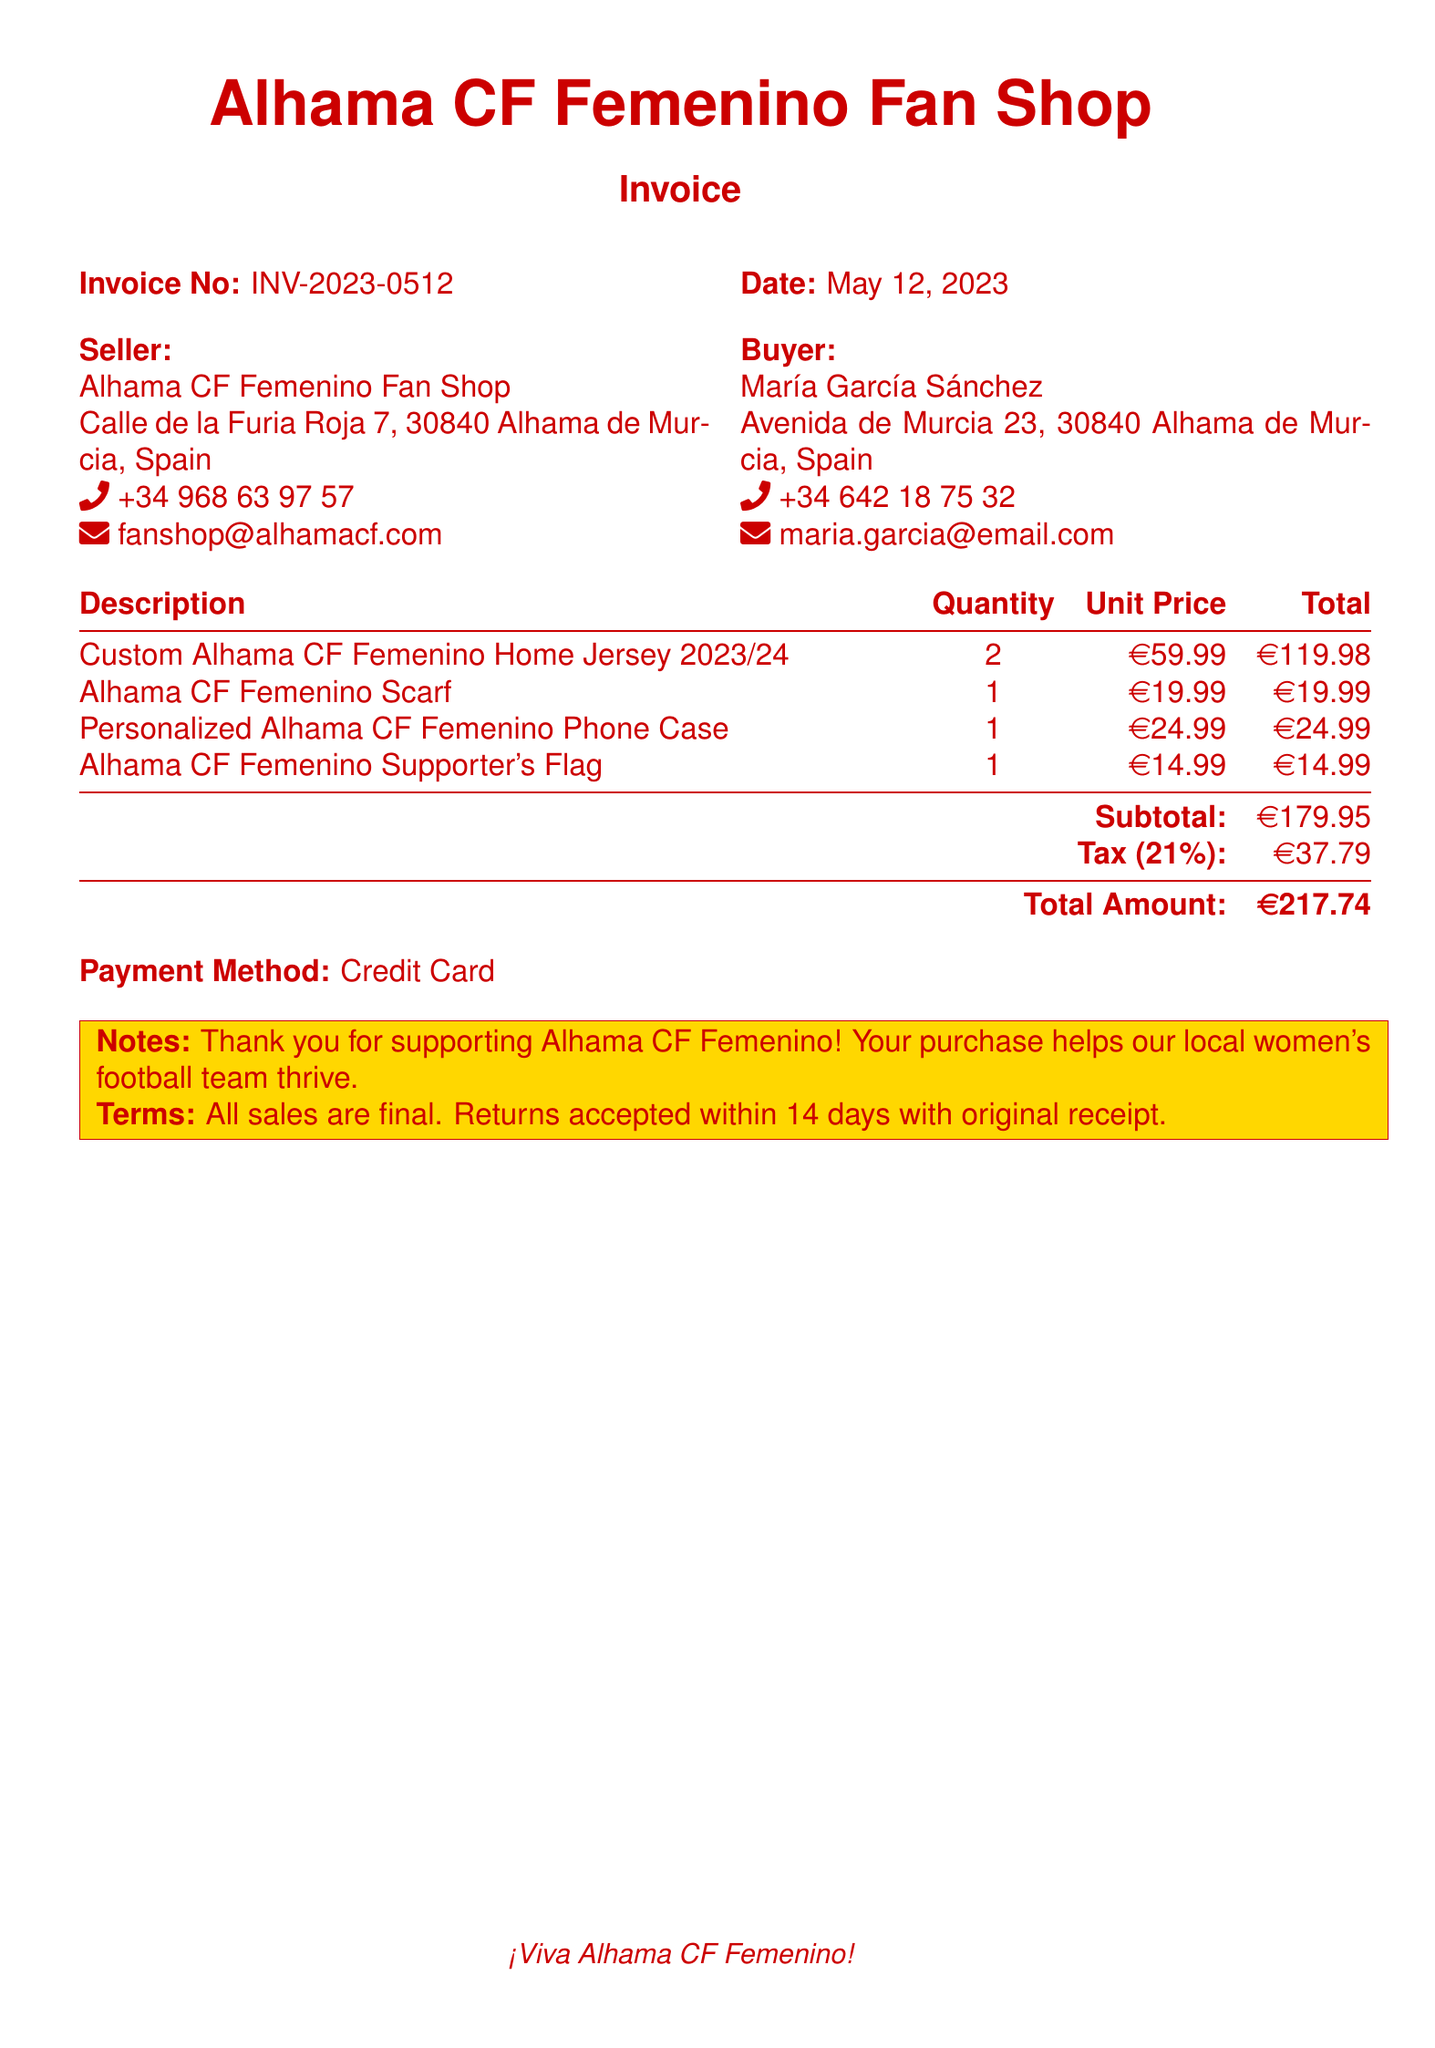What is the invoice number? The invoice number is located in the header section of the document.
Answer: INV-2023-0512 What is the date of the invoice? The date of the invoice is specified next to the invoice number.
Answer: May 12, 2023 How many Custom Alhama CF Femenino Home Jerseys were purchased? The quantity of jerseys purchased is listed in the product description table.
Answer: 2 What is the total amount due? The total amount is stated at the bottom of the summary section of the invoice.
Answer: €217.74 Who is the seller? The seller's name and shop are mentioned at the start of the invoice.
Answer: Alhama CF Femenino Fan Shop What tax percentage was applied? The tax percentage is indicated in the summary section of the invoice.
Answer: 21% What is the personalized item listed in the invoice? The personalized item can be found in the product description.
Answer: Personalized Alhama CF Femenino Phone Case What is the payment method? The payment method is mentioned just before the notes section in the document.
Answer: Credit Card What is the subtotal amount before tax? The subtotal amount is provided in the summary section of the invoice.
Answer: €179.95 